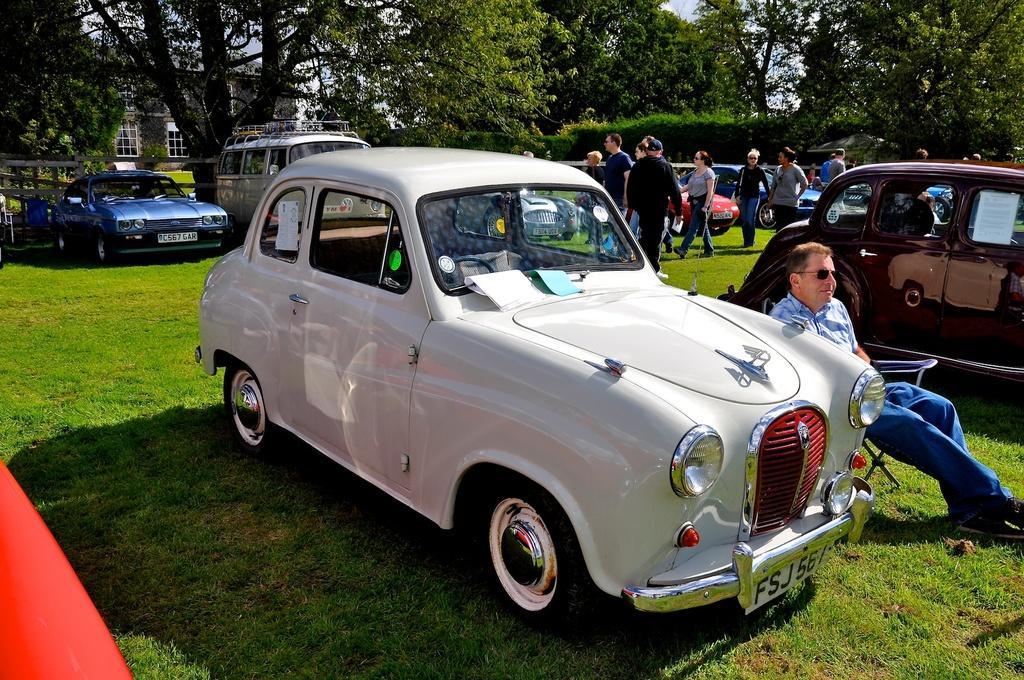In one or two sentences, can you explain what this image depicts? In the image in the center we can see few different color vehicles and we can see one person sitting on the chair. And we can see few people were standing. In the background we can see sky,clouds,trees,building,roof,wall,windows,fence,grass etc. 